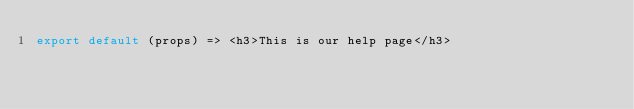Convert code to text. <code><loc_0><loc_0><loc_500><loc_500><_JavaScript_>export default (props) => <h3>This is our help page</h3></code> 